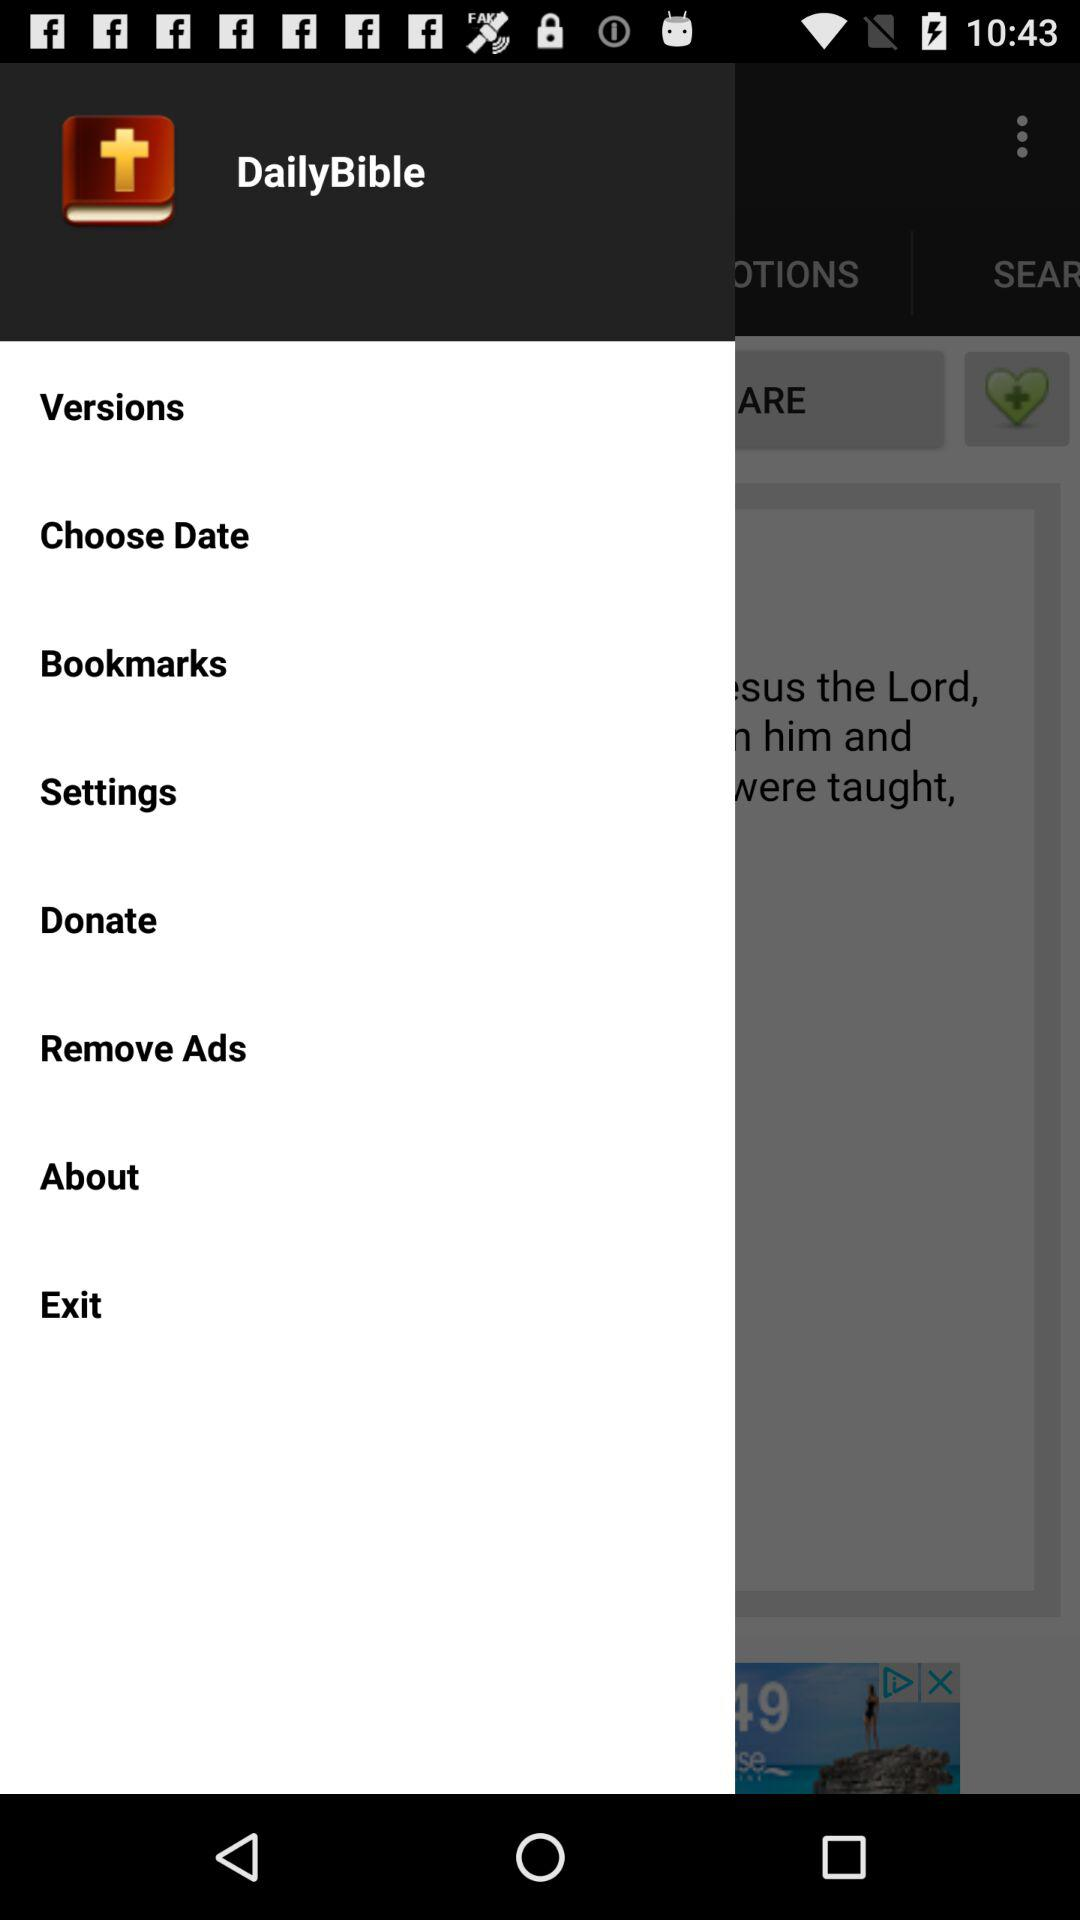What is the app name? The app name is "DailyBible". 